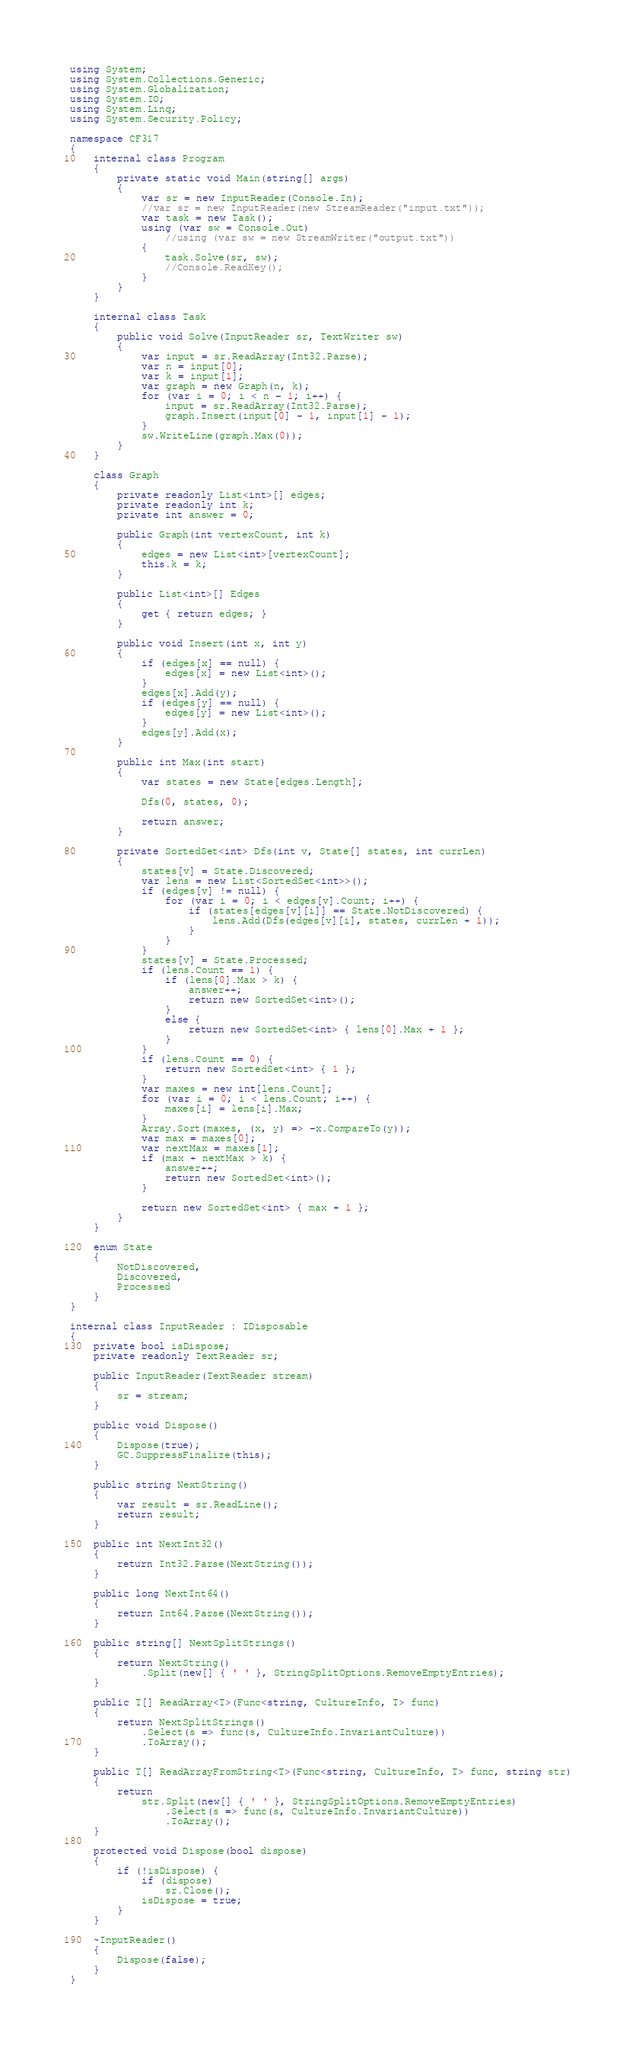Convert code to text. <code><loc_0><loc_0><loc_500><loc_500><_C#_>using System;
using System.Collections.Generic;
using System.Globalization;
using System.IO;
using System.Linq;
using System.Security.Policy;

namespace CF317
{
	internal class Program
	{
		private static void Main(string[] args)
		{
			var sr = new InputReader(Console.In);
			//var sr = new InputReader(new StreamReader("input.txt"));
			var task = new Task();
			using (var sw = Console.Out)
				//using (var sw = new StreamWriter("output.txt"))
			{
				task.Solve(sr, sw);
				//Console.ReadKey();
			}
		}
	}

	internal class Task
	{
		public void Solve(InputReader sr, TextWriter sw)
		{
			var input = sr.ReadArray(Int32.Parse);
			var n = input[0];
			var k = input[1];
			var graph = new Graph(n, k);
			for (var i = 0; i < n - 1; i++) {
				input = sr.ReadArray(Int32.Parse);
				graph.Insert(input[0] - 1, input[1] - 1);
			}
			sw.WriteLine(graph.Max(0));
		}
	}

	class Graph
	{
		private readonly List<int>[] edges;
		private readonly int k;
		private int answer = 0;

		public Graph(int vertexCount, int k)
		{
			edges = new List<int>[vertexCount];
			this.k = k;
		}

		public List<int>[] Edges
		{
			get { return edges; }
		}

		public void Insert(int x, int y)
		{
			if (edges[x] == null) {
				edges[x] = new List<int>();
			}
			edges[x].Add(y);
			if (edges[y] == null) {
				edges[y] = new List<int>();
			}
			edges[y].Add(x);
		}

		public int Max(int start)
		{
			var states = new State[edges.Length];

			Dfs(0, states, 0);

			return answer;
		}

		private SortedSet<int> Dfs(int v, State[] states, int currLen)
		{
			states[v] = State.Discovered;
			var lens = new List<SortedSet<int>>();
			if (edges[v] != null) {
				for (var i = 0; i < edges[v].Count; i++) {
					if (states[edges[v][i]] == State.NotDiscovered) {
						lens.Add(Dfs(edges[v][i], states, currLen + 1));
					}
				}
			}
			states[v] = State.Processed;
			if (lens.Count == 1) {
				if (lens[0].Max > k) {
					answer++;
					return new SortedSet<int>();
				}
				else {
					return new SortedSet<int> { lens[0].Max + 1 };
				}
			}
			if (lens.Count == 0) {
				return new SortedSet<int> { 1 };
			}
			var maxes = new int[lens.Count];
			for (var i = 0; i < lens.Count; i++) {
				maxes[i] = lens[i].Max;
			}
			Array.Sort(maxes, (x, y) => -x.CompareTo(y));
			var max = maxes[0];
			var nextMax = maxes[1];
			if (max + nextMax > k) {
				answer++;
				return new SortedSet<int>();
			}

			return new SortedSet<int> { max + 1 };
		}
	}

	enum State
	{
		NotDiscovered,
		Discovered,
		Processed
	}
}

internal class InputReader : IDisposable
{
	private bool isDispose;
	private readonly TextReader sr;

	public InputReader(TextReader stream)
	{
		sr = stream;
	}

	public void Dispose()
	{
		Dispose(true);
		GC.SuppressFinalize(this);
	}

	public string NextString()
	{
		var result = sr.ReadLine();
		return result;
	}

	public int NextInt32()
	{
		return Int32.Parse(NextString());
	}

	public long NextInt64()
	{
		return Int64.Parse(NextString());
	}

	public string[] NextSplitStrings()
	{
		return NextString()
			.Split(new[] { ' ' }, StringSplitOptions.RemoveEmptyEntries);
	}

	public T[] ReadArray<T>(Func<string, CultureInfo, T> func)
	{
		return NextSplitStrings()
			.Select(s => func(s, CultureInfo.InvariantCulture))
			.ToArray();
	}

	public T[] ReadArrayFromString<T>(Func<string, CultureInfo, T> func, string str)
	{
		return
			str.Split(new[] { ' ' }, StringSplitOptions.RemoveEmptyEntries)
				.Select(s => func(s, CultureInfo.InvariantCulture))
				.ToArray();
	}

	protected void Dispose(bool dispose)
	{
		if (!isDispose) {
			if (dispose)
				sr.Close();
			isDispose = true;
		}
	}

	~InputReader()
	{
		Dispose(false);
	}
}</code> 